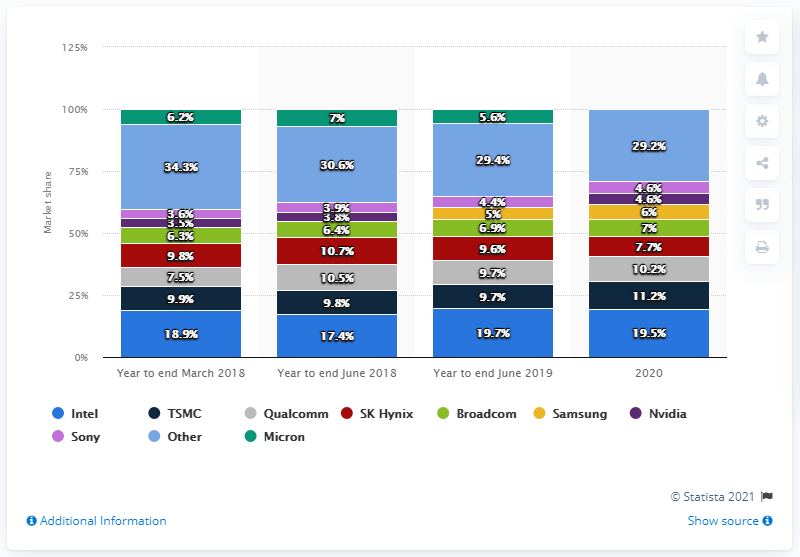Outline some significant characteristics in this image. Intel's sales accounted for 19.5% of the microprocessor market in 2020. According to industry reports, TSMC was the second largest microprocessor manufacturer in 2020. 